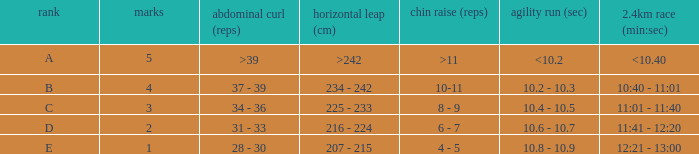Tell me the 2.4km run for points less than 2 12:21 - 13:00. 